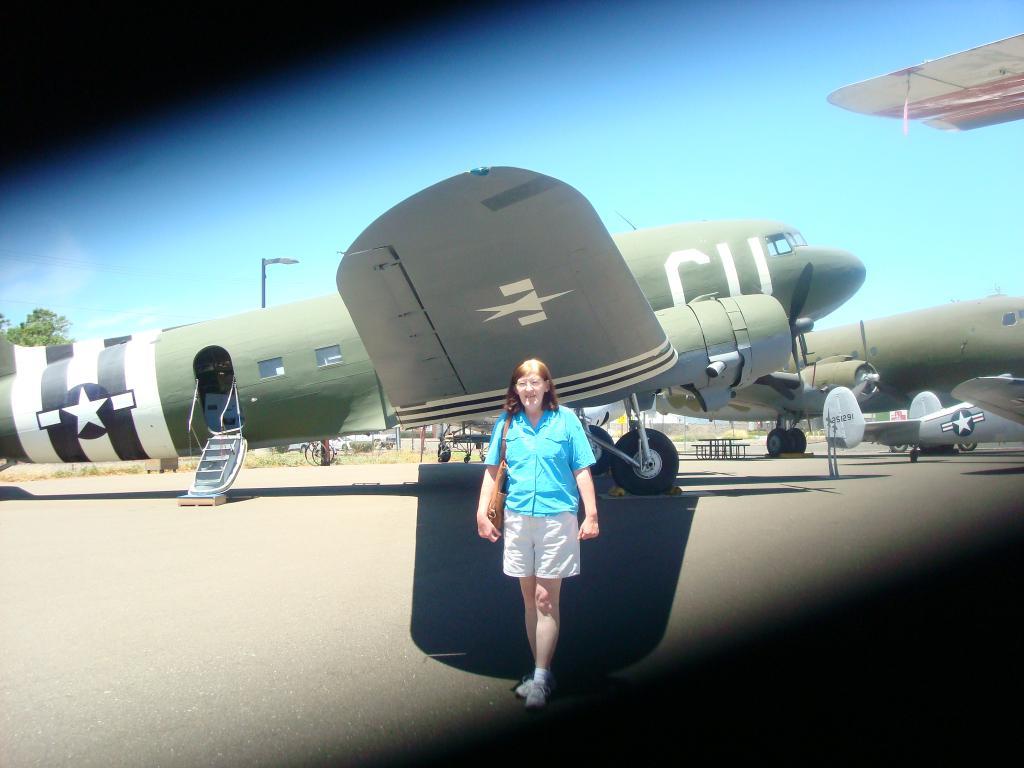What letter is written on the plane closest to the cockpit?
Give a very brief answer. U. 